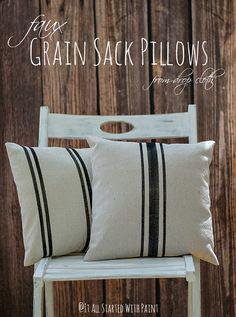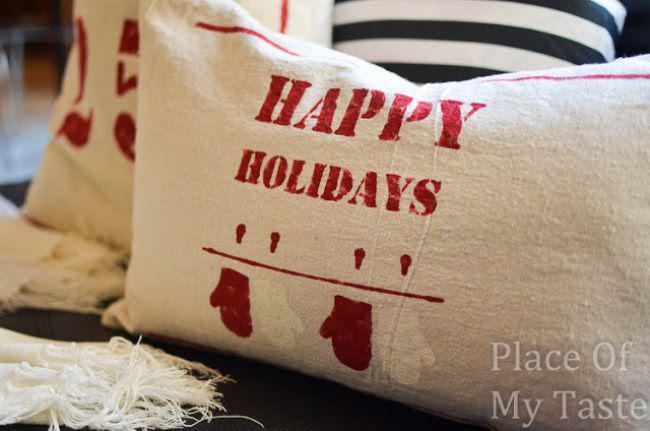The first image is the image on the left, the second image is the image on the right. Assess this claim about the two images: "One image has a pillow with vertical strips going down the center.". Correct or not? Answer yes or no. Yes. 